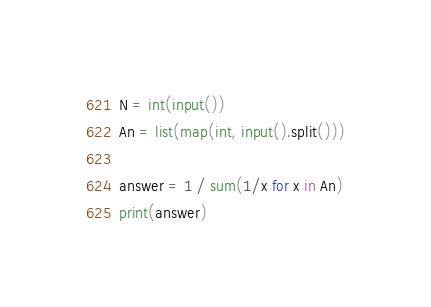<code> <loc_0><loc_0><loc_500><loc_500><_Python_>N = int(input())
An = list(map(int, input().split()))

answer = 1 / sum(1/x for x in An)
print(answer)</code> 